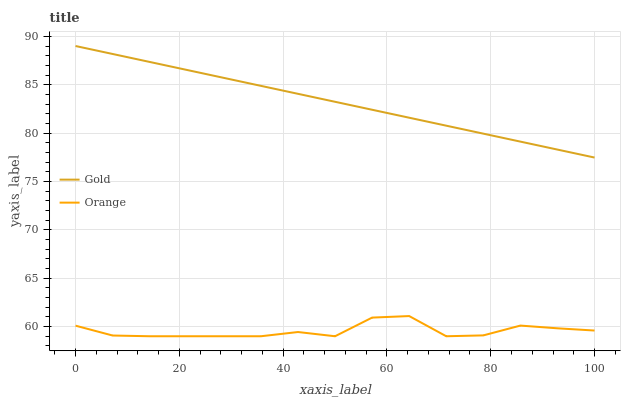Does Orange have the minimum area under the curve?
Answer yes or no. Yes. Does Gold have the maximum area under the curve?
Answer yes or no. Yes. Does Gold have the minimum area under the curve?
Answer yes or no. No. Is Gold the smoothest?
Answer yes or no. Yes. Is Orange the roughest?
Answer yes or no. Yes. Is Gold the roughest?
Answer yes or no. No. Does Orange have the lowest value?
Answer yes or no. Yes. Does Gold have the lowest value?
Answer yes or no. No. Does Gold have the highest value?
Answer yes or no. Yes. Is Orange less than Gold?
Answer yes or no. Yes. Is Gold greater than Orange?
Answer yes or no. Yes. Does Orange intersect Gold?
Answer yes or no. No. 